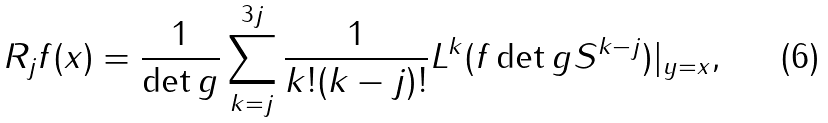Convert formula to latex. <formula><loc_0><loc_0><loc_500><loc_500>R _ { j } f ( x ) = \frac { 1 } { \det g } \sum _ { k = j } ^ { 3 j } \frac { 1 } { k ! ( k - j ) ! } L ^ { k } ( f \det g S ^ { k - j } ) | _ { y = x } ,</formula> 